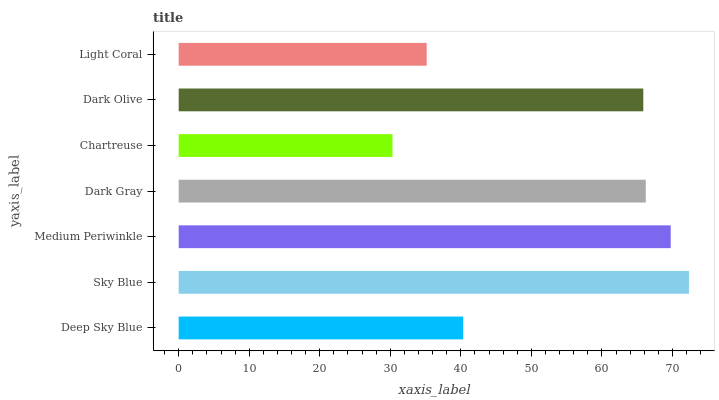Is Chartreuse the minimum?
Answer yes or no. Yes. Is Sky Blue the maximum?
Answer yes or no. Yes. Is Medium Periwinkle the minimum?
Answer yes or no. No. Is Medium Periwinkle the maximum?
Answer yes or no. No. Is Sky Blue greater than Medium Periwinkle?
Answer yes or no. Yes. Is Medium Periwinkle less than Sky Blue?
Answer yes or no. Yes. Is Medium Periwinkle greater than Sky Blue?
Answer yes or no. No. Is Sky Blue less than Medium Periwinkle?
Answer yes or no. No. Is Dark Olive the high median?
Answer yes or no. Yes. Is Dark Olive the low median?
Answer yes or no. Yes. Is Medium Periwinkle the high median?
Answer yes or no. No. Is Chartreuse the low median?
Answer yes or no. No. 